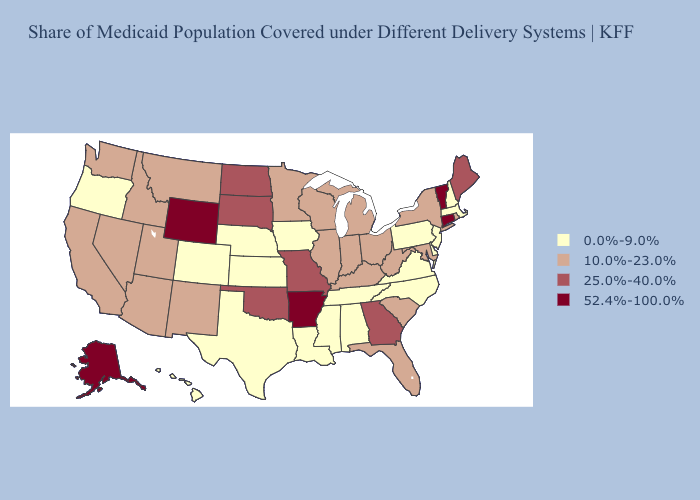Which states have the lowest value in the Northeast?
Short answer required. Massachusetts, New Hampshire, New Jersey, Pennsylvania. Which states hav the highest value in the South?
Short answer required. Arkansas. Name the states that have a value in the range 25.0%-40.0%?
Short answer required. Georgia, Maine, Missouri, North Dakota, Oklahoma, South Dakota. Among the states that border Rhode Island , which have the highest value?
Concise answer only. Connecticut. Name the states that have a value in the range 52.4%-100.0%?
Keep it brief. Alaska, Arkansas, Connecticut, Vermont, Wyoming. Among the states that border Missouri , does Arkansas have the highest value?
Answer briefly. Yes. What is the value of South Dakota?
Answer briefly. 25.0%-40.0%. Does West Virginia have the lowest value in the South?
Keep it brief. No. What is the lowest value in the West?
Concise answer only. 0.0%-9.0%. Does New York have a higher value than Texas?
Short answer required. Yes. Name the states that have a value in the range 10.0%-23.0%?
Concise answer only. Arizona, California, Florida, Idaho, Illinois, Indiana, Kentucky, Maryland, Michigan, Minnesota, Montana, Nevada, New Mexico, New York, Ohio, Rhode Island, South Carolina, Utah, Washington, West Virginia, Wisconsin. Name the states that have a value in the range 52.4%-100.0%?
Write a very short answer. Alaska, Arkansas, Connecticut, Vermont, Wyoming. Name the states that have a value in the range 52.4%-100.0%?
Give a very brief answer. Alaska, Arkansas, Connecticut, Vermont, Wyoming. Does Alaska have the highest value in the USA?
Write a very short answer. Yes. Among the states that border Maryland , does Delaware have the lowest value?
Quick response, please. Yes. 